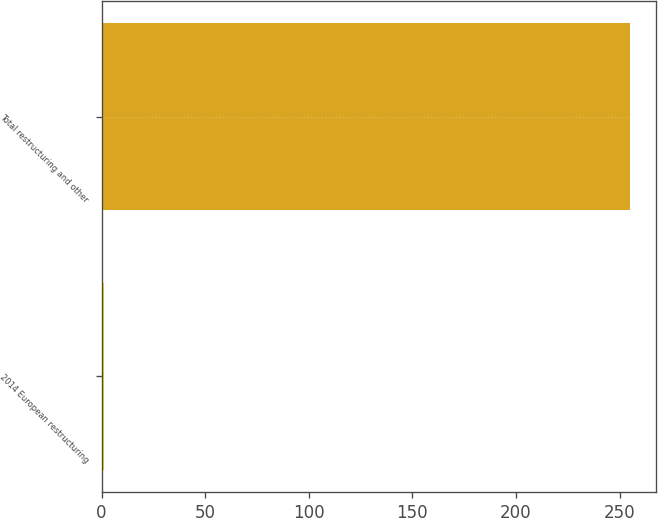Convert chart. <chart><loc_0><loc_0><loc_500><loc_500><bar_chart><fcel>2014 European restructuring<fcel>Total restructuring and other<nl><fcel>1<fcel>255<nl></chart> 